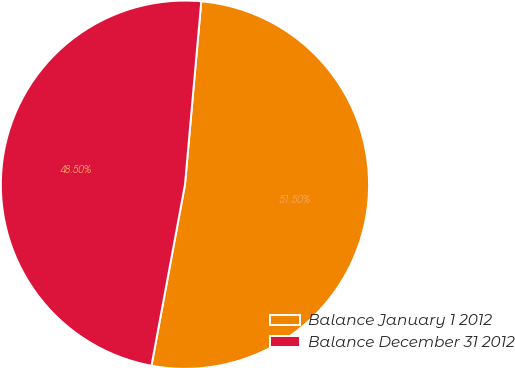<chart> <loc_0><loc_0><loc_500><loc_500><pie_chart><fcel>Balance January 1 2012<fcel>Balance December 31 2012<nl><fcel>51.5%<fcel>48.5%<nl></chart> 